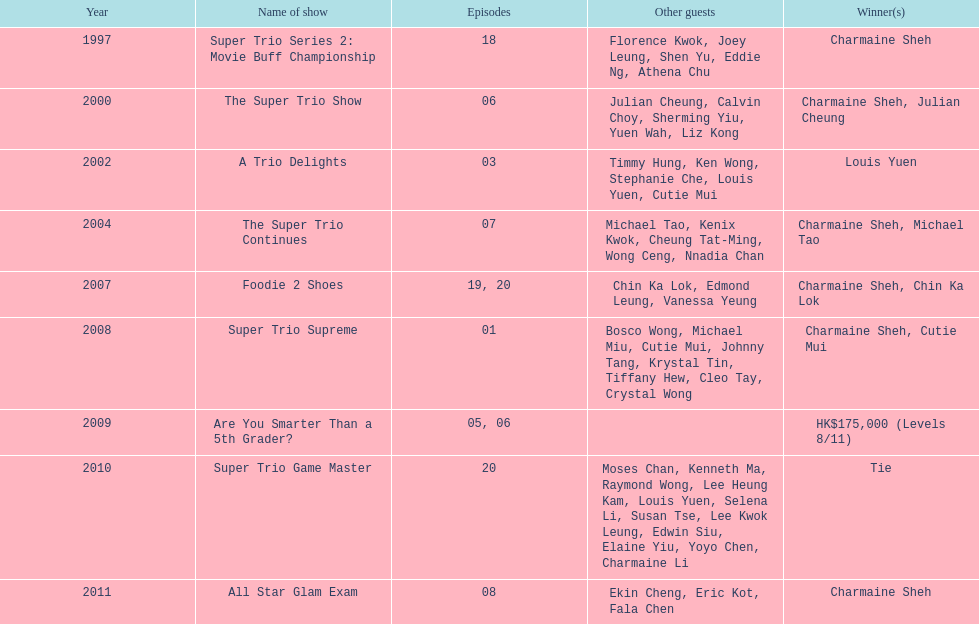What is the number of shows with a minimum of 5 episodes? 7. 